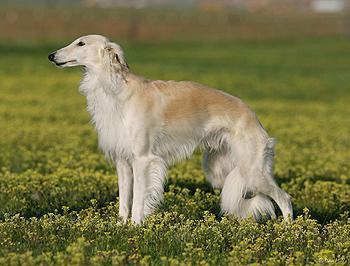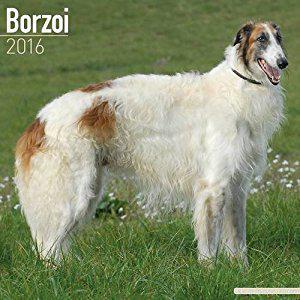The first image is the image on the left, the second image is the image on the right. Considering the images on both sides, is "One of the images contains exactly two dogs." valid? Answer yes or no. No. 